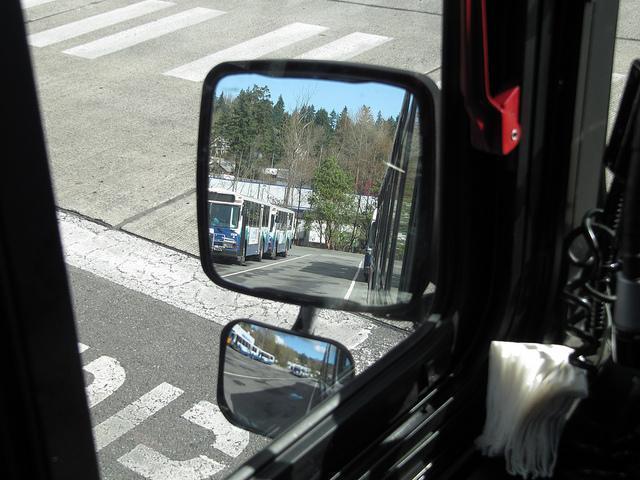How many birds are in this photo?
Give a very brief answer. 0. 